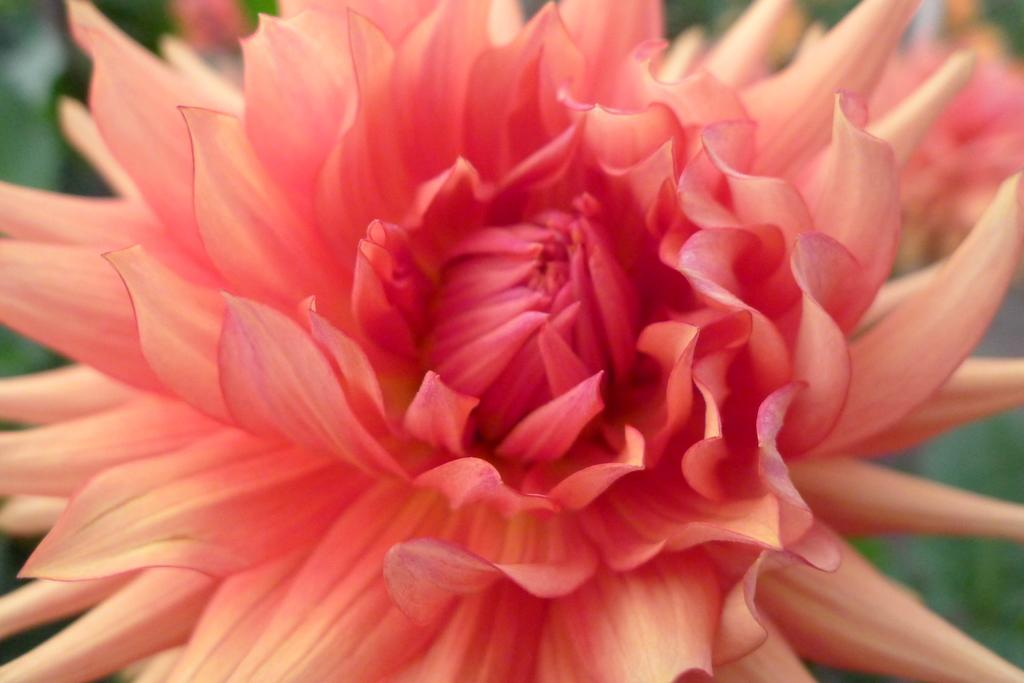What is the main subject of the image? There is a flower in the image. Can you describe the background of the image? The background of the image is blurred. What theory is being discussed on the shelf in the image? There is no shelf or discussion of a theory present in the image; it features a flower with a blurred background. 